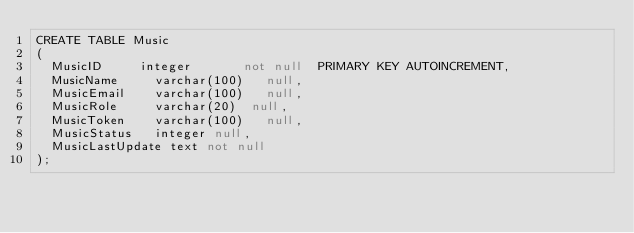<code> <loc_0><loc_0><loc_500><loc_500><_SQL_>CREATE TABLE Music
(
	MusicID			integer		    not null	PRIMARY KEY AUTOINCREMENT,
	MusicName			varchar(100)	 null,
	MusicEmail		varchar(100)	 null,
	MusicRole			varchar(20)	 null,
	MusicToken		varchar(100)	 null,
	MusicStatus		integer null,
	MusicLastUpdate	text not null
);
</code> 